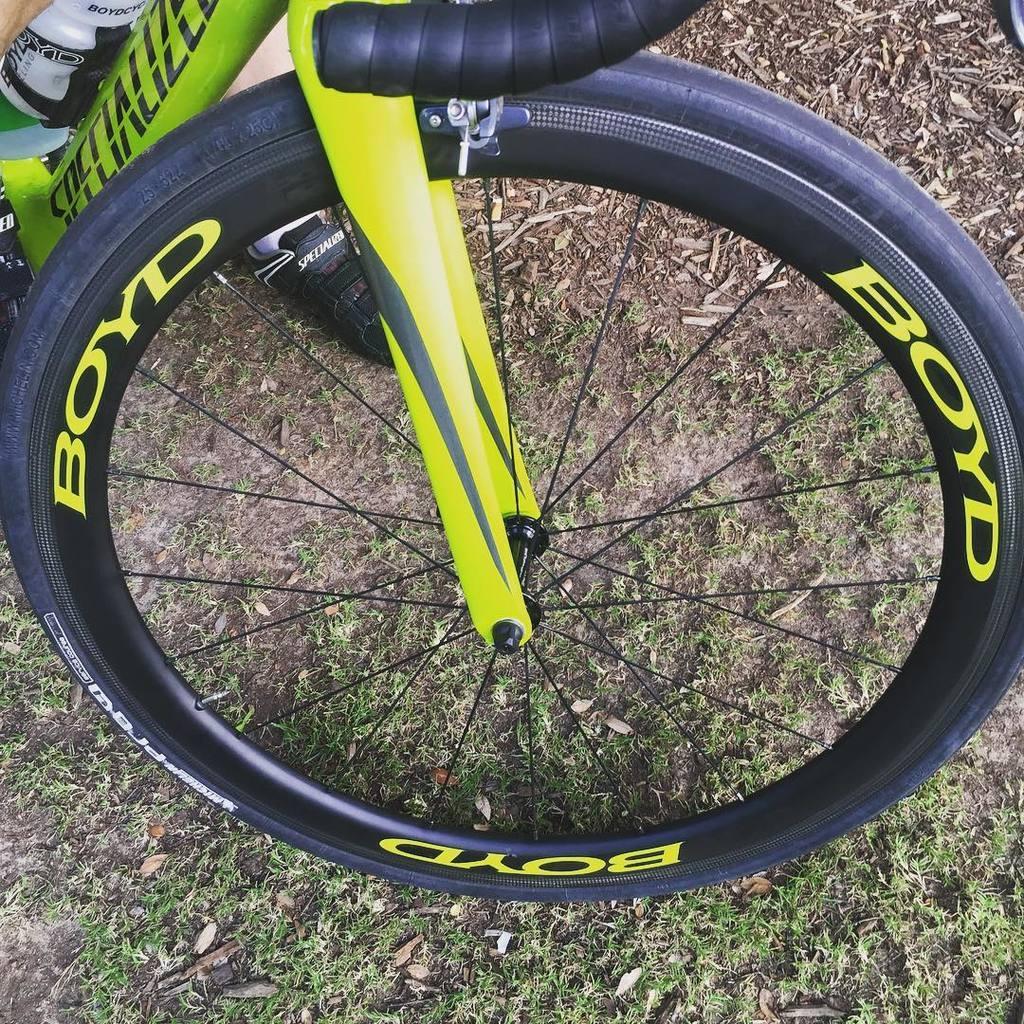In one or two sentences, can you explain what this image depicts? In this picture I can see the front part of a bicycle, there is a leg of a person, and in the background there is grass. 